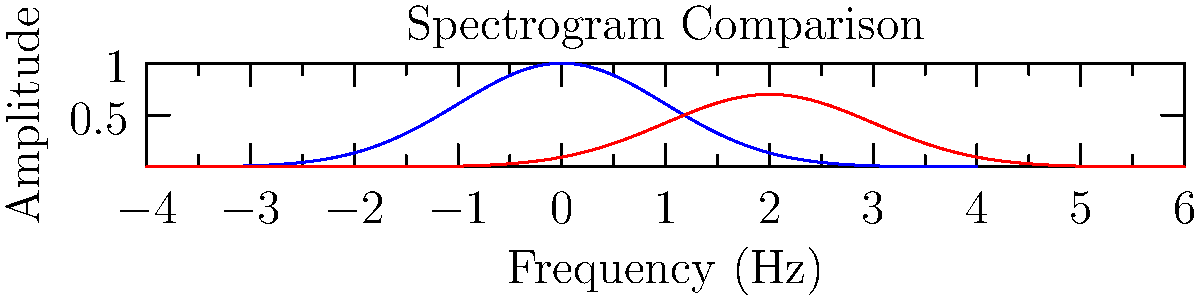Analyze the spectrogram comparing a traditional orchestral instrument (blue curve) and a modern orchestral instrument (red curve). What key difference in timbre does this comparison reveal, and how might this impact the overall sound in a contemporary orchestral composition? To answer this question, let's analyze the spectrogram step-by-step:

1. Curve shape: 
   - The blue curve (traditional instrument) has a higher peak amplitude and is centered around the y-axis.
   - The red curve (modern instrument) has a lower peak amplitude and is shifted to the right.

2. Frequency distribution:
   - The traditional instrument's energy is concentrated in lower frequencies (centered around 0 Hz).
   - The modern instrument's energy is spread across a wider range of frequencies, with its peak shifted towards higher frequencies.

3. Amplitude:
   - The traditional instrument has a higher peak amplitude, suggesting a stronger fundamental frequency.
   - The modern instrument has a lower peak amplitude but maintains significant energy across a broader spectrum.

4. Harmonic content:
   - The traditional instrument's curve suggests a more pronounced fundamental frequency with fewer overtones.
   - The modern instrument's curve indicates a richer harmonic content with more prominent overtones.

5. Impact on timbre:
   - The traditional instrument likely has a purer, more focused tone due to its strong fundamental and fewer overtones.
   - The modern instrument probably has a more complex, possibly brighter timbre due to its richer harmonic content.

6. Effect on orchestral composition:
   - In a contemporary orchestral composition, the modern instrument would add more timbral complexity and potentially brighter tones.
   - The traditional instrument would provide a more foundational, pure tone that could anchor the overall sound.
   - The combination of both would allow for a wider range of tonal colors and textures in the composition.
Answer: The modern instrument exhibits a wider frequency spectrum with more prominent overtones, resulting in a more complex timbre that adds tonal richness to contemporary orchestral compositions. 